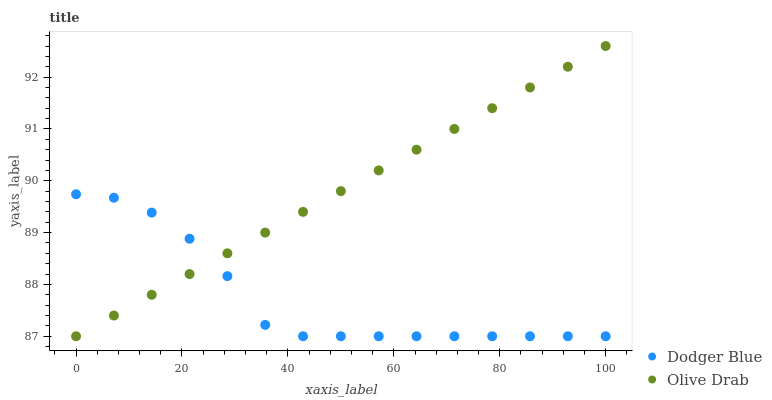Does Dodger Blue have the minimum area under the curve?
Answer yes or no. Yes. Does Olive Drab have the maximum area under the curve?
Answer yes or no. Yes. Does Olive Drab have the minimum area under the curve?
Answer yes or no. No. Is Olive Drab the smoothest?
Answer yes or no. Yes. Is Dodger Blue the roughest?
Answer yes or no. Yes. Is Olive Drab the roughest?
Answer yes or no. No. Does Dodger Blue have the lowest value?
Answer yes or no. Yes. Does Olive Drab have the highest value?
Answer yes or no. Yes. Does Olive Drab intersect Dodger Blue?
Answer yes or no. Yes. Is Olive Drab less than Dodger Blue?
Answer yes or no. No. Is Olive Drab greater than Dodger Blue?
Answer yes or no. No. 